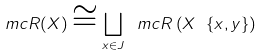<formula> <loc_0><loc_0><loc_500><loc_500>\ m c R ( X ) \cong \bigsqcup _ { x \in J } \ m c R \left ( X \ \{ x , y \} \right )</formula> 